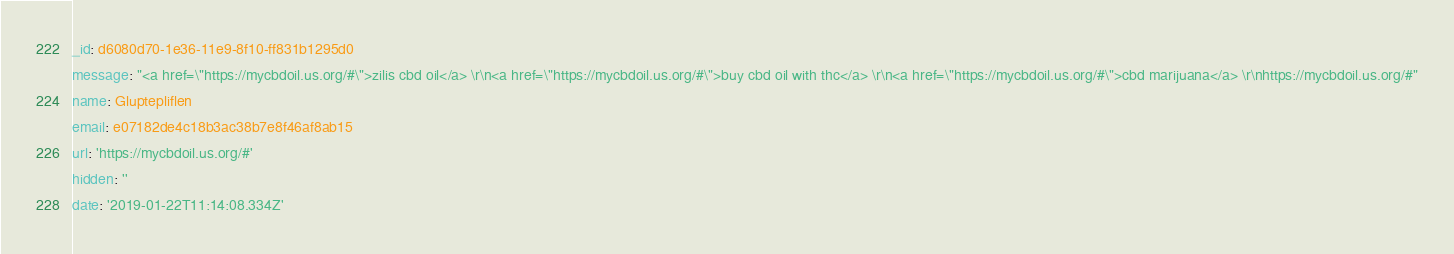Convert code to text. <code><loc_0><loc_0><loc_500><loc_500><_YAML_>_id: d6080d70-1e36-11e9-8f10-ff831b1295d0
message: "<a href=\"https://mycbdoil.us.org/#\">zilis cbd oil</a> \r\n<a href=\"https://mycbdoil.us.org/#\">buy cbd oil with thc</a> \r\n<a href=\"https://mycbdoil.us.org/#\">cbd marijuana</a> \r\nhttps://mycbdoil.us.org/#"
name: Gluptepliflen
email: e07182de4c18b3ac38b7e8f46af8ab15
url: 'https://mycbdoil.us.org/#'
hidden: ''
date: '2019-01-22T11:14:08.334Z'
</code> 